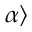Convert formula to latex. <formula><loc_0><loc_0><loc_500><loc_500>\alpha \rangle</formula> 